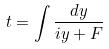Convert formula to latex. <formula><loc_0><loc_0><loc_500><loc_500>t = \int \frac { d y } { i y + F }</formula> 